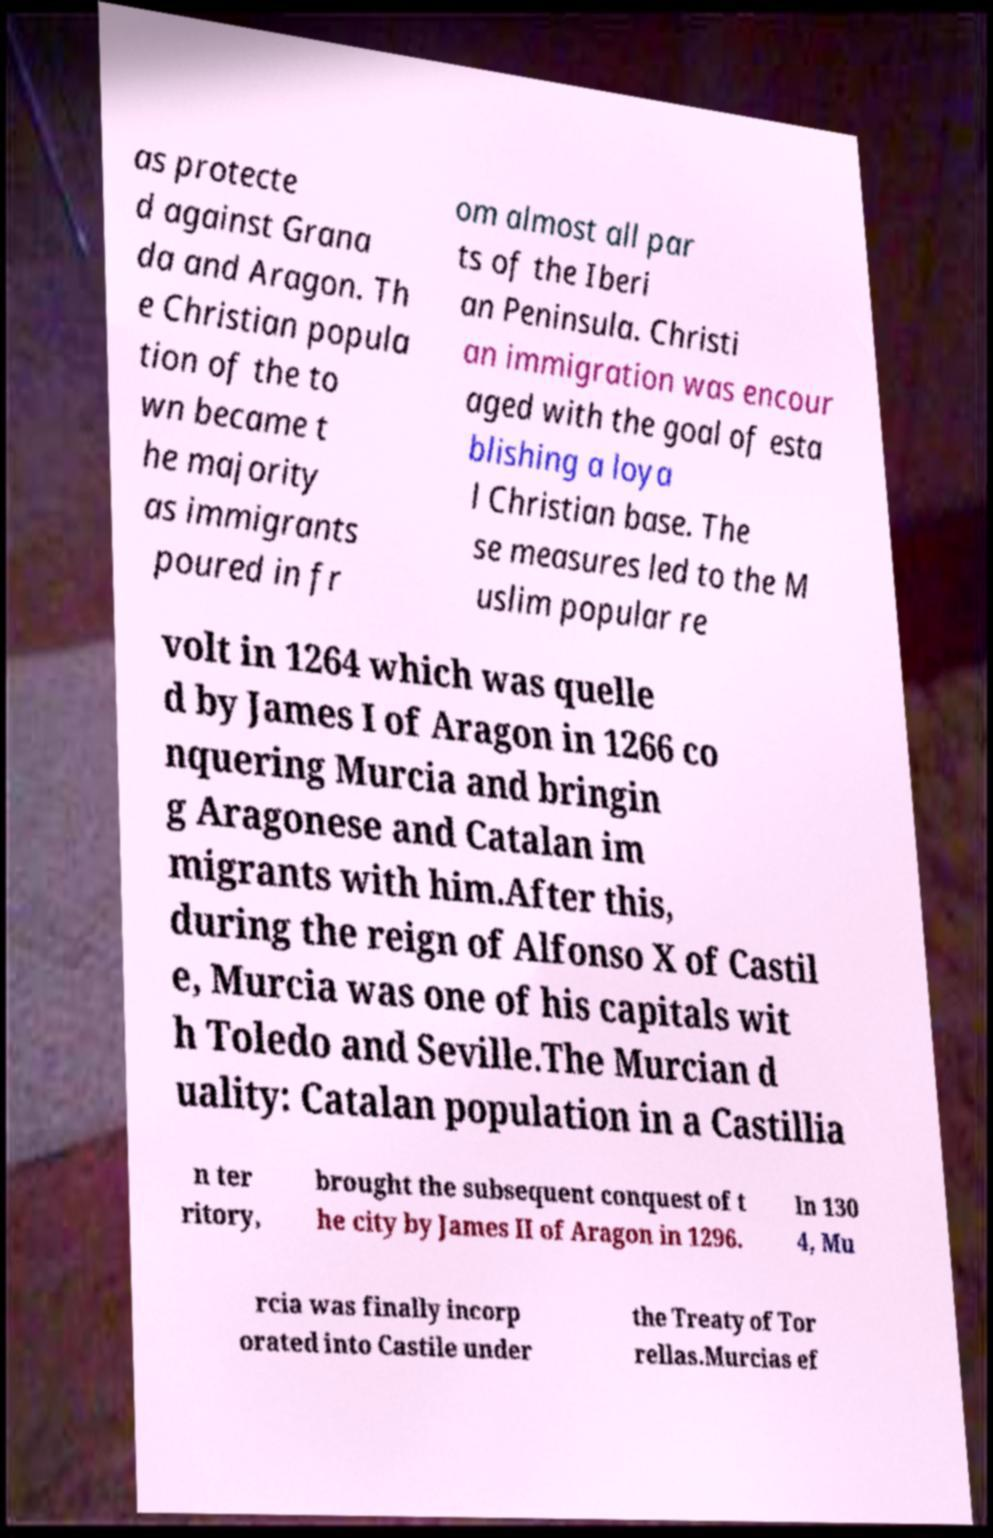Can you accurately transcribe the text from the provided image for me? as protecte d against Grana da and Aragon. Th e Christian popula tion of the to wn became t he majority as immigrants poured in fr om almost all par ts of the Iberi an Peninsula. Christi an immigration was encour aged with the goal of esta blishing a loya l Christian base. The se measures led to the M uslim popular re volt in 1264 which was quelle d by James I of Aragon in 1266 co nquering Murcia and bringin g Aragonese and Catalan im migrants with him.After this, during the reign of Alfonso X of Castil e, Murcia was one of his capitals wit h Toledo and Seville.The Murcian d uality: Catalan population in a Castillia n ter ritory, brought the subsequent conquest of t he city by James II of Aragon in 1296. In 130 4, Mu rcia was finally incorp orated into Castile under the Treaty of Tor rellas.Murcias ef 